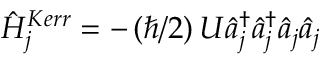<formula> <loc_0><loc_0><loc_500><loc_500>\hat { H } _ { j } ^ { K e r r } = - \left ( \hbar { / } 2 \right ) U \hat { a } _ { j } ^ { \dagger } \hat { a } _ { j } ^ { \dagger } \hat { a } _ { j } \hat { a } _ { j }</formula> 